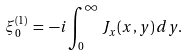<formula> <loc_0><loc_0><loc_500><loc_500>\xi _ { 0 } ^ { ( 1 ) } \, = \, - i \int _ { 0 } ^ { \infty } J _ { x } ( x , y ) \, d y .</formula> 